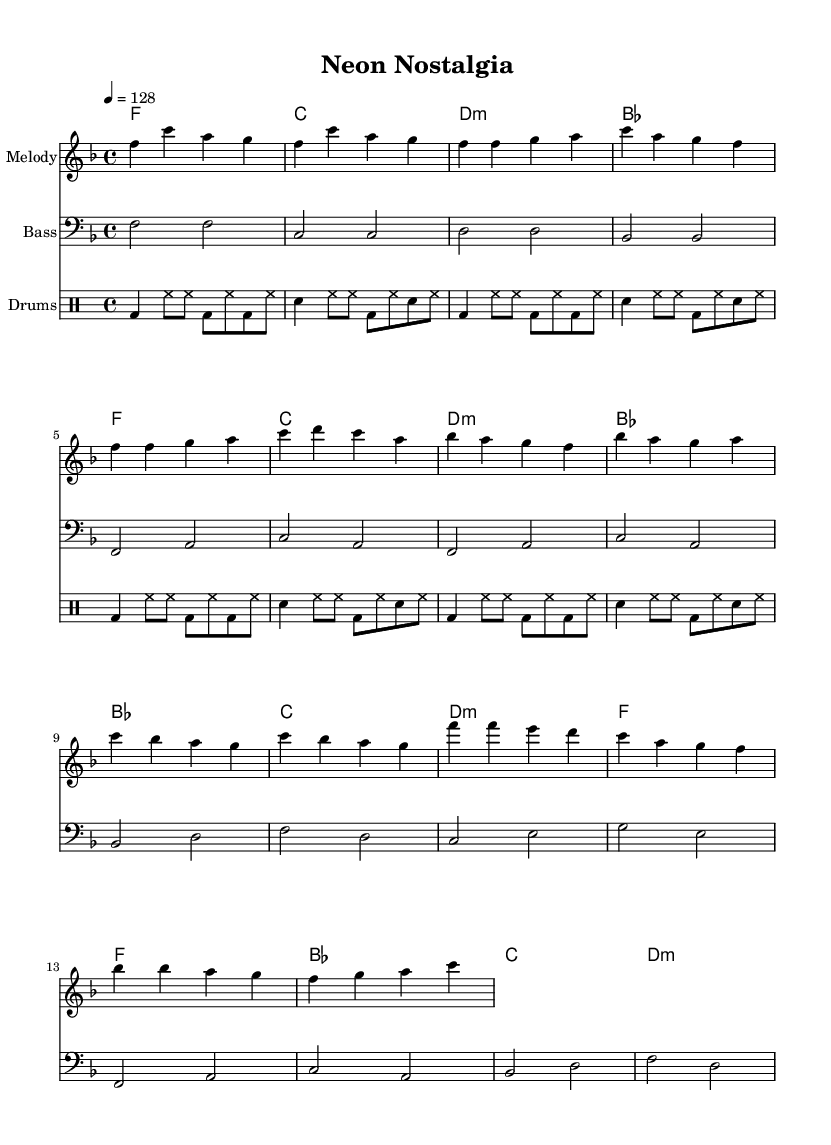What is the key signature of this music? The key signature is F major, which includes one flat (B-flat). You can identify this at the beginning of the sheet music.
Answer: F major What is the time signature? The time signature is 4/4, which indicates four beats per measure and a quarter note receives one beat. This is displayed next to the key signature at the beginning.
Answer: 4/4 What is the tempo marking? The tempo marking is indicated as 128 beats per minute, which suggests a moderate upbeat pace typical in electronic music. You can find this marking notated as "4 = 128" in the global section of the code.
Answer: 128 How many measures are in the chorus section? The chorus section contains four measures. By counting the measures in the melody part labeled as chorus, you can see this clearly.
Answer: 4 Which chord is used in the pre-chorus section? The pre-chorus features the chords B-flat, C, D minor, and F. These are listed consecutively in the harmonies section for the pre-chorus.
Answer: B-flat, C, D minor, F What instrumental parts are included in this score? The score includes three instrumental parts: Melody, Bass, and Drums. Each part is visually separated into distinct staffs. This can be observed in the structure of the score.
Answer: Melody, Bass, Drums What stylistic influence can be identified in this piece? The upbeat electro-pop style is influenced by retro elements, which is evident in the chord progressions and melodic choices. This is inferred from the title "Neon Nostalgia" and the musical characteristics aligned with electronic music.
Answer: Electro-pop, retro 